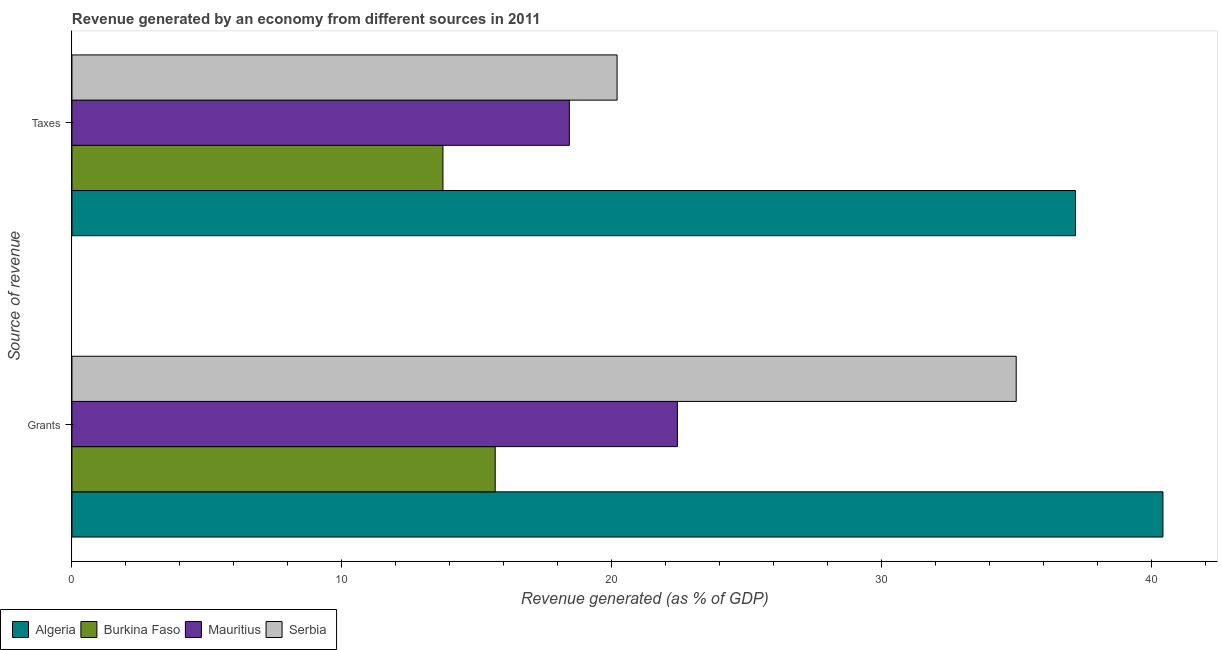What is the label of the 2nd group of bars from the top?
Provide a short and direct response. Grants. What is the revenue generated by grants in Serbia?
Ensure brevity in your answer.  34.99. Across all countries, what is the maximum revenue generated by taxes?
Offer a very short reply. 37.19. Across all countries, what is the minimum revenue generated by grants?
Give a very brief answer. 15.68. In which country was the revenue generated by grants maximum?
Your answer should be compact. Algeria. In which country was the revenue generated by taxes minimum?
Make the answer very short. Burkina Faso. What is the total revenue generated by taxes in the graph?
Your answer should be very brief. 89.56. What is the difference between the revenue generated by taxes in Mauritius and that in Burkina Faso?
Offer a very short reply. 4.68. What is the difference between the revenue generated by taxes in Burkina Faso and the revenue generated by grants in Serbia?
Your answer should be compact. -21.24. What is the average revenue generated by taxes per country?
Your answer should be compact. 22.39. What is the difference between the revenue generated by taxes and revenue generated by grants in Serbia?
Your answer should be compact. -14.79. In how many countries, is the revenue generated by taxes greater than 14 %?
Provide a succinct answer. 3. What is the ratio of the revenue generated by grants in Algeria to that in Mauritius?
Ensure brevity in your answer.  1.8. In how many countries, is the revenue generated by taxes greater than the average revenue generated by taxes taken over all countries?
Make the answer very short. 1. What does the 4th bar from the top in Taxes represents?
Offer a very short reply. Algeria. What does the 1st bar from the bottom in Taxes represents?
Give a very brief answer. Algeria. How many bars are there?
Keep it short and to the point. 8. How many countries are there in the graph?
Your response must be concise. 4. Are the values on the major ticks of X-axis written in scientific E-notation?
Ensure brevity in your answer.  No. Where does the legend appear in the graph?
Give a very brief answer. Bottom left. How many legend labels are there?
Keep it short and to the point. 4. What is the title of the graph?
Your answer should be compact. Revenue generated by an economy from different sources in 2011. Does "Liberia" appear as one of the legend labels in the graph?
Make the answer very short. No. What is the label or title of the X-axis?
Make the answer very short. Revenue generated (as % of GDP). What is the label or title of the Y-axis?
Offer a terse response. Source of revenue. What is the Revenue generated (as % of GDP) of Algeria in Grants?
Give a very brief answer. 40.43. What is the Revenue generated (as % of GDP) in Burkina Faso in Grants?
Offer a terse response. 15.68. What is the Revenue generated (as % of GDP) in Mauritius in Grants?
Your answer should be very brief. 22.43. What is the Revenue generated (as % of GDP) of Serbia in Grants?
Your response must be concise. 34.99. What is the Revenue generated (as % of GDP) in Algeria in Taxes?
Your answer should be compact. 37.19. What is the Revenue generated (as % of GDP) in Burkina Faso in Taxes?
Provide a succinct answer. 13.75. What is the Revenue generated (as % of GDP) in Mauritius in Taxes?
Ensure brevity in your answer.  18.43. What is the Revenue generated (as % of GDP) in Serbia in Taxes?
Your answer should be very brief. 20.2. Across all Source of revenue, what is the maximum Revenue generated (as % of GDP) of Algeria?
Your response must be concise. 40.43. Across all Source of revenue, what is the maximum Revenue generated (as % of GDP) of Burkina Faso?
Keep it short and to the point. 15.68. Across all Source of revenue, what is the maximum Revenue generated (as % of GDP) in Mauritius?
Make the answer very short. 22.43. Across all Source of revenue, what is the maximum Revenue generated (as % of GDP) of Serbia?
Your response must be concise. 34.99. Across all Source of revenue, what is the minimum Revenue generated (as % of GDP) in Algeria?
Keep it short and to the point. 37.19. Across all Source of revenue, what is the minimum Revenue generated (as % of GDP) in Burkina Faso?
Give a very brief answer. 13.75. Across all Source of revenue, what is the minimum Revenue generated (as % of GDP) in Mauritius?
Provide a succinct answer. 18.43. Across all Source of revenue, what is the minimum Revenue generated (as % of GDP) of Serbia?
Give a very brief answer. 20.2. What is the total Revenue generated (as % of GDP) of Algeria in the graph?
Provide a succinct answer. 77.61. What is the total Revenue generated (as % of GDP) of Burkina Faso in the graph?
Provide a short and direct response. 29.43. What is the total Revenue generated (as % of GDP) in Mauritius in the graph?
Provide a succinct answer. 40.86. What is the total Revenue generated (as % of GDP) in Serbia in the graph?
Give a very brief answer. 55.19. What is the difference between the Revenue generated (as % of GDP) of Algeria in Grants and that in Taxes?
Ensure brevity in your answer.  3.24. What is the difference between the Revenue generated (as % of GDP) in Burkina Faso in Grants and that in Taxes?
Make the answer very short. 1.94. What is the difference between the Revenue generated (as % of GDP) in Mauritius in Grants and that in Taxes?
Make the answer very short. 4. What is the difference between the Revenue generated (as % of GDP) in Serbia in Grants and that in Taxes?
Offer a very short reply. 14.79. What is the difference between the Revenue generated (as % of GDP) of Algeria in Grants and the Revenue generated (as % of GDP) of Burkina Faso in Taxes?
Offer a terse response. 26.68. What is the difference between the Revenue generated (as % of GDP) of Algeria in Grants and the Revenue generated (as % of GDP) of Mauritius in Taxes?
Make the answer very short. 22. What is the difference between the Revenue generated (as % of GDP) of Algeria in Grants and the Revenue generated (as % of GDP) of Serbia in Taxes?
Your response must be concise. 20.23. What is the difference between the Revenue generated (as % of GDP) in Burkina Faso in Grants and the Revenue generated (as % of GDP) in Mauritius in Taxes?
Offer a very short reply. -2.75. What is the difference between the Revenue generated (as % of GDP) in Burkina Faso in Grants and the Revenue generated (as % of GDP) in Serbia in Taxes?
Make the answer very short. -4.52. What is the difference between the Revenue generated (as % of GDP) in Mauritius in Grants and the Revenue generated (as % of GDP) in Serbia in Taxes?
Provide a succinct answer. 2.23. What is the average Revenue generated (as % of GDP) in Algeria per Source of revenue?
Keep it short and to the point. 38.81. What is the average Revenue generated (as % of GDP) of Burkina Faso per Source of revenue?
Your response must be concise. 14.71. What is the average Revenue generated (as % of GDP) of Mauritius per Source of revenue?
Provide a succinct answer. 20.43. What is the average Revenue generated (as % of GDP) in Serbia per Source of revenue?
Keep it short and to the point. 27.59. What is the difference between the Revenue generated (as % of GDP) in Algeria and Revenue generated (as % of GDP) in Burkina Faso in Grants?
Keep it short and to the point. 24.74. What is the difference between the Revenue generated (as % of GDP) of Algeria and Revenue generated (as % of GDP) of Mauritius in Grants?
Ensure brevity in your answer.  17.99. What is the difference between the Revenue generated (as % of GDP) in Algeria and Revenue generated (as % of GDP) in Serbia in Grants?
Make the answer very short. 5.44. What is the difference between the Revenue generated (as % of GDP) in Burkina Faso and Revenue generated (as % of GDP) in Mauritius in Grants?
Provide a succinct answer. -6.75. What is the difference between the Revenue generated (as % of GDP) of Burkina Faso and Revenue generated (as % of GDP) of Serbia in Grants?
Give a very brief answer. -19.31. What is the difference between the Revenue generated (as % of GDP) in Mauritius and Revenue generated (as % of GDP) in Serbia in Grants?
Provide a succinct answer. -12.55. What is the difference between the Revenue generated (as % of GDP) in Algeria and Revenue generated (as % of GDP) in Burkina Faso in Taxes?
Your response must be concise. 23.44. What is the difference between the Revenue generated (as % of GDP) in Algeria and Revenue generated (as % of GDP) in Mauritius in Taxes?
Offer a terse response. 18.76. What is the difference between the Revenue generated (as % of GDP) in Algeria and Revenue generated (as % of GDP) in Serbia in Taxes?
Your answer should be very brief. 16.99. What is the difference between the Revenue generated (as % of GDP) in Burkina Faso and Revenue generated (as % of GDP) in Mauritius in Taxes?
Offer a very short reply. -4.68. What is the difference between the Revenue generated (as % of GDP) in Burkina Faso and Revenue generated (as % of GDP) in Serbia in Taxes?
Ensure brevity in your answer.  -6.45. What is the difference between the Revenue generated (as % of GDP) in Mauritius and Revenue generated (as % of GDP) in Serbia in Taxes?
Provide a succinct answer. -1.77. What is the ratio of the Revenue generated (as % of GDP) in Algeria in Grants to that in Taxes?
Your answer should be very brief. 1.09. What is the ratio of the Revenue generated (as % of GDP) in Burkina Faso in Grants to that in Taxes?
Offer a terse response. 1.14. What is the ratio of the Revenue generated (as % of GDP) in Mauritius in Grants to that in Taxes?
Your response must be concise. 1.22. What is the ratio of the Revenue generated (as % of GDP) in Serbia in Grants to that in Taxes?
Your answer should be very brief. 1.73. What is the difference between the highest and the second highest Revenue generated (as % of GDP) of Algeria?
Give a very brief answer. 3.24. What is the difference between the highest and the second highest Revenue generated (as % of GDP) in Burkina Faso?
Keep it short and to the point. 1.94. What is the difference between the highest and the second highest Revenue generated (as % of GDP) of Mauritius?
Make the answer very short. 4. What is the difference between the highest and the second highest Revenue generated (as % of GDP) in Serbia?
Your answer should be compact. 14.79. What is the difference between the highest and the lowest Revenue generated (as % of GDP) of Algeria?
Provide a short and direct response. 3.24. What is the difference between the highest and the lowest Revenue generated (as % of GDP) in Burkina Faso?
Your response must be concise. 1.94. What is the difference between the highest and the lowest Revenue generated (as % of GDP) of Mauritius?
Keep it short and to the point. 4. What is the difference between the highest and the lowest Revenue generated (as % of GDP) in Serbia?
Your response must be concise. 14.79. 